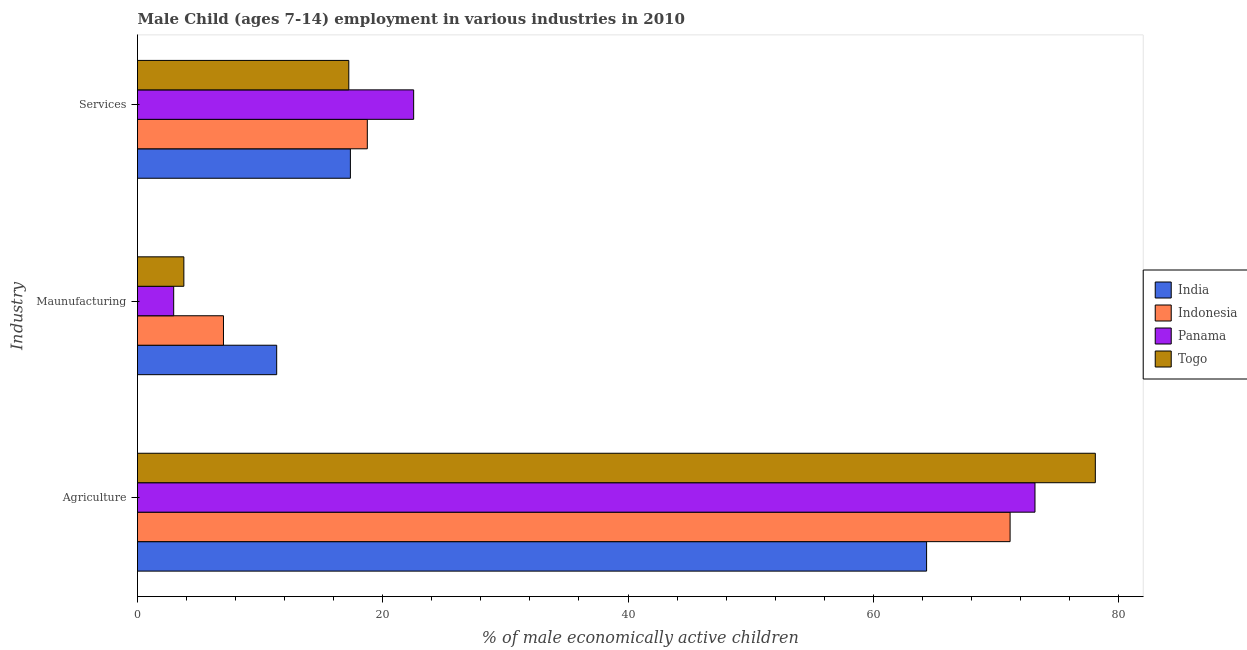Are the number of bars per tick equal to the number of legend labels?
Give a very brief answer. Yes. Are the number of bars on each tick of the Y-axis equal?
Make the answer very short. Yes. How many bars are there on the 3rd tick from the top?
Offer a very short reply. 4. What is the label of the 1st group of bars from the top?
Make the answer very short. Services. What is the percentage of economically active children in manufacturing in Panama?
Provide a succinct answer. 2.95. Across all countries, what is the maximum percentage of economically active children in agriculture?
Ensure brevity in your answer.  78.11. Across all countries, what is the minimum percentage of economically active children in agriculture?
Offer a very short reply. 64.35. In which country was the percentage of economically active children in agriculture maximum?
Offer a very short reply. Togo. What is the total percentage of economically active children in manufacturing in the graph?
Ensure brevity in your answer.  25.09. What is the difference between the percentage of economically active children in manufacturing in Indonesia and that in Togo?
Your response must be concise. 3.23. What is the difference between the percentage of economically active children in agriculture in Togo and the percentage of economically active children in services in Panama?
Make the answer very short. 55.59. What is the average percentage of economically active children in agriculture per country?
Your answer should be compact. 71.7. What is the difference between the percentage of economically active children in agriculture and percentage of economically active children in manufacturing in India?
Give a very brief answer. 53. In how many countries, is the percentage of economically active children in manufacturing greater than 20 %?
Ensure brevity in your answer.  0. What is the ratio of the percentage of economically active children in manufacturing in Panama to that in Togo?
Provide a short and direct response. 0.78. Is the percentage of economically active children in services in Panama less than that in Togo?
Provide a short and direct response. No. What is the difference between the highest and the second highest percentage of economically active children in services?
Make the answer very short. 3.78. What is the difference between the highest and the lowest percentage of economically active children in services?
Keep it short and to the point. 5.29. What does the 3rd bar from the top in Maunufacturing represents?
Offer a terse response. Indonesia. What does the 4th bar from the bottom in Maunufacturing represents?
Provide a succinct answer. Togo. Are all the bars in the graph horizontal?
Your answer should be compact. Yes. How many countries are there in the graph?
Provide a succinct answer. 4. Does the graph contain grids?
Your answer should be very brief. No. What is the title of the graph?
Give a very brief answer. Male Child (ages 7-14) employment in various industries in 2010. Does "Monaco" appear as one of the legend labels in the graph?
Keep it short and to the point. No. What is the label or title of the X-axis?
Give a very brief answer. % of male economically active children. What is the label or title of the Y-axis?
Offer a very short reply. Industry. What is the % of male economically active children in India in Agriculture?
Offer a terse response. 64.35. What is the % of male economically active children in Indonesia in Agriculture?
Your answer should be very brief. 71.16. What is the % of male economically active children in Panama in Agriculture?
Make the answer very short. 73.19. What is the % of male economically active children in Togo in Agriculture?
Give a very brief answer. 78.11. What is the % of male economically active children of India in Maunufacturing?
Give a very brief answer. 11.35. What is the % of male economically active children in Indonesia in Maunufacturing?
Keep it short and to the point. 7.01. What is the % of male economically active children of Panama in Maunufacturing?
Provide a short and direct response. 2.95. What is the % of male economically active children in Togo in Maunufacturing?
Make the answer very short. 3.78. What is the % of male economically active children in India in Services?
Give a very brief answer. 17.36. What is the % of male economically active children in Indonesia in Services?
Provide a succinct answer. 18.74. What is the % of male economically active children in Panama in Services?
Your response must be concise. 22.52. What is the % of male economically active children of Togo in Services?
Keep it short and to the point. 17.23. Across all Industry, what is the maximum % of male economically active children in India?
Give a very brief answer. 64.35. Across all Industry, what is the maximum % of male economically active children in Indonesia?
Keep it short and to the point. 71.16. Across all Industry, what is the maximum % of male economically active children in Panama?
Ensure brevity in your answer.  73.19. Across all Industry, what is the maximum % of male economically active children of Togo?
Keep it short and to the point. 78.11. Across all Industry, what is the minimum % of male economically active children of India?
Your answer should be compact. 11.35. Across all Industry, what is the minimum % of male economically active children of Indonesia?
Provide a short and direct response. 7.01. Across all Industry, what is the minimum % of male economically active children of Panama?
Offer a very short reply. 2.95. Across all Industry, what is the minimum % of male economically active children in Togo?
Offer a very short reply. 3.78. What is the total % of male economically active children in India in the graph?
Offer a very short reply. 93.06. What is the total % of male economically active children in Indonesia in the graph?
Your response must be concise. 96.91. What is the total % of male economically active children of Panama in the graph?
Keep it short and to the point. 98.66. What is the total % of male economically active children of Togo in the graph?
Offer a very short reply. 99.12. What is the difference between the % of male economically active children of Indonesia in Agriculture and that in Maunufacturing?
Offer a terse response. 64.15. What is the difference between the % of male economically active children in Panama in Agriculture and that in Maunufacturing?
Your answer should be very brief. 70.24. What is the difference between the % of male economically active children in Togo in Agriculture and that in Maunufacturing?
Your answer should be compact. 74.33. What is the difference between the % of male economically active children of India in Agriculture and that in Services?
Offer a very short reply. 46.99. What is the difference between the % of male economically active children of Indonesia in Agriculture and that in Services?
Make the answer very short. 52.42. What is the difference between the % of male economically active children in Panama in Agriculture and that in Services?
Give a very brief answer. 50.67. What is the difference between the % of male economically active children of Togo in Agriculture and that in Services?
Your answer should be compact. 60.88. What is the difference between the % of male economically active children of India in Maunufacturing and that in Services?
Provide a succinct answer. -6.01. What is the difference between the % of male economically active children in Indonesia in Maunufacturing and that in Services?
Give a very brief answer. -11.73. What is the difference between the % of male economically active children of Panama in Maunufacturing and that in Services?
Give a very brief answer. -19.57. What is the difference between the % of male economically active children of Togo in Maunufacturing and that in Services?
Make the answer very short. -13.45. What is the difference between the % of male economically active children in India in Agriculture and the % of male economically active children in Indonesia in Maunufacturing?
Make the answer very short. 57.34. What is the difference between the % of male economically active children in India in Agriculture and the % of male economically active children in Panama in Maunufacturing?
Ensure brevity in your answer.  61.4. What is the difference between the % of male economically active children of India in Agriculture and the % of male economically active children of Togo in Maunufacturing?
Provide a succinct answer. 60.57. What is the difference between the % of male economically active children of Indonesia in Agriculture and the % of male economically active children of Panama in Maunufacturing?
Make the answer very short. 68.21. What is the difference between the % of male economically active children in Indonesia in Agriculture and the % of male economically active children in Togo in Maunufacturing?
Ensure brevity in your answer.  67.38. What is the difference between the % of male economically active children in Panama in Agriculture and the % of male economically active children in Togo in Maunufacturing?
Offer a very short reply. 69.41. What is the difference between the % of male economically active children of India in Agriculture and the % of male economically active children of Indonesia in Services?
Make the answer very short. 45.61. What is the difference between the % of male economically active children in India in Agriculture and the % of male economically active children in Panama in Services?
Your response must be concise. 41.83. What is the difference between the % of male economically active children in India in Agriculture and the % of male economically active children in Togo in Services?
Provide a short and direct response. 47.12. What is the difference between the % of male economically active children of Indonesia in Agriculture and the % of male economically active children of Panama in Services?
Give a very brief answer. 48.64. What is the difference between the % of male economically active children of Indonesia in Agriculture and the % of male economically active children of Togo in Services?
Keep it short and to the point. 53.93. What is the difference between the % of male economically active children in Panama in Agriculture and the % of male economically active children in Togo in Services?
Your answer should be very brief. 55.96. What is the difference between the % of male economically active children of India in Maunufacturing and the % of male economically active children of Indonesia in Services?
Offer a terse response. -7.39. What is the difference between the % of male economically active children in India in Maunufacturing and the % of male economically active children in Panama in Services?
Provide a succinct answer. -11.17. What is the difference between the % of male economically active children of India in Maunufacturing and the % of male economically active children of Togo in Services?
Your answer should be compact. -5.88. What is the difference between the % of male economically active children in Indonesia in Maunufacturing and the % of male economically active children in Panama in Services?
Make the answer very short. -15.51. What is the difference between the % of male economically active children of Indonesia in Maunufacturing and the % of male economically active children of Togo in Services?
Give a very brief answer. -10.22. What is the difference between the % of male economically active children in Panama in Maunufacturing and the % of male economically active children in Togo in Services?
Provide a short and direct response. -14.28. What is the average % of male economically active children in India per Industry?
Make the answer very short. 31.02. What is the average % of male economically active children of Indonesia per Industry?
Provide a succinct answer. 32.3. What is the average % of male economically active children in Panama per Industry?
Your answer should be compact. 32.89. What is the average % of male economically active children of Togo per Industry?
Your response must be concise. 33.04. What is the difference between the % of male economically active children of India and % of male economically active children of Indonesia in Agriculture?
Make the answer very short. -6.81. What is the difference between the % of male economically active children in India and % of male economically active children in Panama in Agriculture?
Provide a succinct answer. -8.84. What is the difference between the % of male economically active children in India and % of male economically active children in Togo in Agriculture?
Your answer should be very brief. -13.76. What is the difference between the % of male economically active children of Indonesia and % of male economically active children of Panama in Agriculture?
Your answer should be very brief. -2.03. What is the difference between the % of male economically active children of Indonesia and % of male economically active children of Togo in Agriculture?
Provide a short and direct response. -6.95. What is the difference between the % of male economically active children of Panama and % of male economically active children of Togo in Agriculture?
Provide a succinct answer. -4.92. What is the difference between the % of male economically active children of India and % of male economically active children of Indonesia in Maunufacturing?
Your answer should be very brief. 4.34. What is the difference between the % of male economically active children of India and % of male economically active children of Togo in Maunufacturing?
Provide a short and direct response. 7.57. What is the difference between the % of male economically active children in Indonesia and % of male economically active children in Panama in Maunufacturing?
Give a very brief answer. 4.06. What is the difference between the % of male economically active children in Indonesia and % of male economically active children in Togo in Maunufacturing?
Offer a terse response. 3.23. What is the difference between the % of male economically active children of Panama and % of male economically active children of Togo in Maunufacturing?
Give a very brief answer. -0.83. What is the difference between the % of male economically active children in India and % of male economically active children in Indonesia in Services?
Give a very brief answer. -1.38. What is the difference between the % of male economically active children of India and % of male economically active children of Panama in Services?
Ensure brevity in your answer.  -5.16. What is the difference between the % of male economically active children in India and % of male economically active children in Togo in Services?
Offer a very short reply. 0.13. What is the difference between the % of male economically active children of Indonesia and % of male economically active children of Panama in Services?
Your answer should be compact. -3.78. What is the difference between the % of male economically active children of Indonesia and % of male economically active children of Togo in Services?
Make the answer very short. 1.51. What is the difference between the % of male economically active children of Panama and % of male economically active children of Togo in Services?
Your response must be concise. 5.29. What is the ratio of the % of male economically active children in India in Agriculture to that in Maunufacturing?
Provide a short and direct response. 5.67. What is the ratio of the % of male economically active children of Indonesia in Agriculture to that in Maunufacturing?
Offer a terse response. 10.15. What is the ratio of the % of male economically active children in Panama in Agriculture to that in Maunufacturing?
Give a very brief answer. 24.81. What is the ratio of the % of male economically active children of Togo in Agriculture to that in Maunufacturing?
Give a very brief answer. 20.66. What is the ratio of the % of male economically active children in India in Agriculture to that in Services?
Provide a short and direct response. 3.71. What is the ratio of the % of male economically active children of Indonesia in Agriculture to that in Services?
Offer a very short reply. 3.8. What is the ratio of the % of male economically active children of Panama in Agriculture to that in Services?
Give a very brief answer. 3.25. What is the ratio of the % of male economically active children of Togo in Agriculture to that in Services?
Your response must be concise. 4.53. What is the ratio of the % of male economically active children in India in Maunufacturing to that in Services?
Your answer should be compact. 0.65. What is the ratio of the % of male economically active children in Indonesia in Maunufacturing to that in Services?
Provide a succinct answer. 0.37. What is the ratio of the % of male economically active children of Panama in Maunufacturing to that in Services?
Your answer should be very brief. 0.13. What is the ratio of the % of male economically active children in Togo in Maunufacturing to that in Services?
Offer a terse response. 0.22. What is the difference between the highest and the second highest % of male economically active children of India?
Your answer should be compact. 46.99. What is the difference between the highest and the second highest % of male economically active children of Indonesia?
Your response must be concise. 52.42. What is the difference between the highest and the second highest % of male economically active children of Panama?
Your answer should be very brief. 50.67. What is the difference between the highest and the second highest % of male economically active children of Togo?
Offer a very short reply. 60.88. What is the difference between the highest and the lowest % of male economically active children in India?
Your answer should be compact. 53. What is the difference between the highest and the lowest % of male economically active children in Indonesia?
Your answer should be compact. 64.15. What is the difference between the highest and the lowest % of male economically active children of Panama?
Your answer should be compact. 70.24. What is the difference between the highest and the lowest % of male economically active children in Togo?
Your response must be concise. 74.33. 